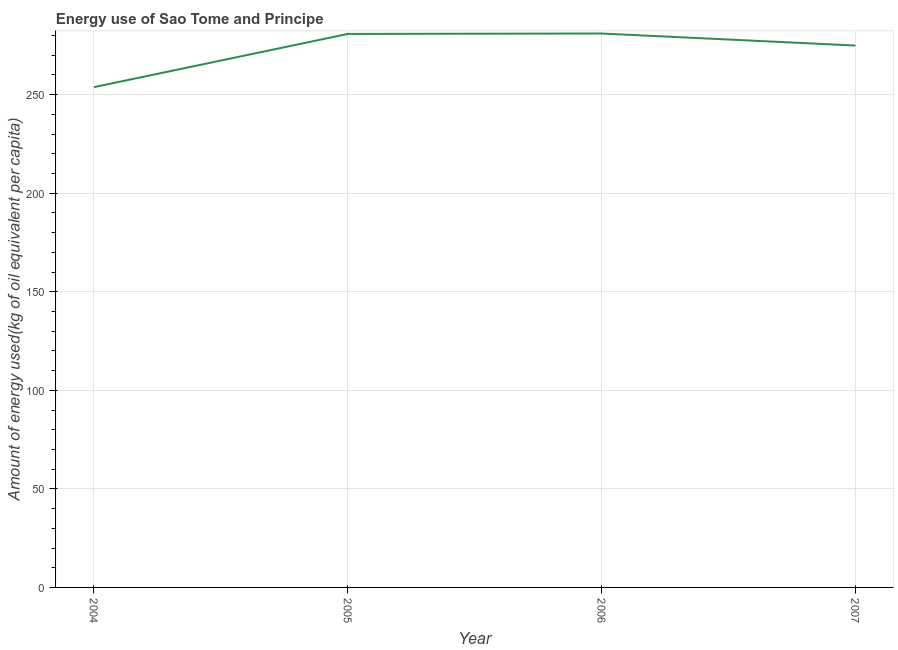What is the amount of energy used in 2007?
Keep it short and to the point. 274.89. Across all years, what is the maximum amount of energy used?
Give a very brief answer. 281. Across all years, what is the minimum amount of energy used?
Give a very brief answer. 253.79. In which year was the amount of energy used maximum?
Offer a very short reply. 2006. In which year was the amount of energy used minimum?
Provide a short and direct response. 2004. What is the sum of the amount of energy used?
Keep it short and to the point. 1090.45. What is the difference between the amount of energy used in 2004 and 2005?
Provide a short and direct response. -26.99. What is the average amount of energy used per year?
Your response must be concise. 272.61. What is the median amount of energy used?
Your response must be concise. 277.83. Do a majority of the years between 2006 and 2004 (inclusive) have amount of energy used greater than 70 kg?
Your answer should be very brief. No. What is the ratio of the amount of energy used in 2004 to that in 2005?
Give a very brief answer. 0.9. Is the amount of energy used in 2005 less than that in 2006?
Your response must be concise. Yes. Is the difference between the amount of energy used in 2005 and 2007 greater than the difference between any two years?
Ensure brevity in your answer.  No. What is the difference between the highest and the second highest amount of energy used?
Provide a short and direct response. 0.22. Is the sum of the amount of energy used in 2005 and 2007 greater than the maximum amount of energy used across all years?
Offer a very short reply. Yes. What is the difference between the highest and the lowest amount of energy used?
Your answer should be very brief. 27.21. In how many years, is the amount of energy used greater than the average amount of energy used taken over all years?
Ensure brevity in your answer.  3. Does the amount of energy used monotonically increase over the years?
Your answer should be very brief. No. How many lines are there?
Offer a terse response. 1. How many years are there in the graph?
Provide a succinct answer. 4. What is the difference between two consecutive major ticks on the Y-axis?
Keep it short and to the point. 50. Does the graph contain grids?
Offer a very short reply. Yes. What is the title of the graph?
Give a very brief answer. Energy use of Sao Tome and Principe. What is the label or title of the Y-axis?
Ensure brevity in your answer.  Amount of energy used(kg of oil equivalent per capita). What is the Amount of energy used(kg of oil equivalent per capita) of 2004?
Your answer should be very brief. 253.79. What is the Amount of energy used(kg of oil equivalent per capita) of 2005?
Provide a succinct answer. 280.78. What is the Amount of energy used(kg of oil equivalent per capita) of 2006?
Your answer should be very brief. 281. What is the Amount of energy used(kg of oil equivalent per capita) in 2007?
Ensure brevity in your answer.  274.89. What is the difference between the Amount of energy used(kg of oil equivalent per capita) in 2004 and 2005?
Keep it short and to the point. -26.99. What is the difference between the Amount of energy used(kg of oil equivalent per capita) in 2004 and 2006?
Your answer should be very brief. -27.21. What is the difference between the Amount of energy used(kg of oil equivalent per capita) in 2004 and 2007?
Your response must be concise. -21.1. What is the difference between the Amount of energy used(kg of oil equivalent per capita) in 2005 and 2006?
Offer a very short reply. -0.22. What is the difference between the Amount of energy used(kg of oil equivalent per capita) in 2005 and 2007?
Your answer should be very brief. 5.89. What is the difference between the Amount of energy used(kg of oil equivalent per capita) in 2006 and 2007?
Your answer should be compact. 6.11. What is the ratio of the Amount of energy used(kg of oil equivalent per capita) in 2004 to that in 2005?
Make the answer very short. 0.9. What is the ratio of the Amount of energy used(kg of oil equivalent per capita) in 2004 to that in 2006?
Ensure brevity in your answer.  0.9. What is the ratio of the Amount of energy used(kg of oil equivalent per capita) in 2004 to that in 2007?
Offer a very short reply. 0.92. What is the ratio of the Amount of energy used(kg of oil equivalent per capita) in 2005 to that in 2006?
Make the answer very short. 1. What is the ratio of the Amount of energy used(kg of oil equivalent per capita) in 2005 to that in 2007?
Make the answer very short. 1.02. 